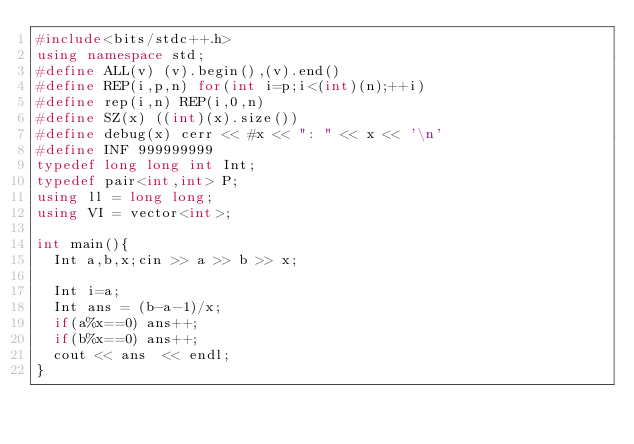Convert code to text. <code><loc_0><loc_0><loc_500><loc_500><_C++_>#include<bits/stdc++.h>
using namespace std;
#define ALL(v) (v).begin(),(v).end()
#define REP(i,p,n) for(int i=p;i<(int)(n);++i)
#define rep(i,n) REP(i,0,n)
#define SZ(x) ((int)(x).size())
#define debug(x) cerr << #x << ": " << x << '\n'
#define INF 999999999
typedef long long int Int;
typedef pair<int,int> P;
using ll = long long;
using VI = vector<int>;

int main(){
  Int a,b,x;cin >> a >> b >> x;

  Int i=a;
  Int ans = (b-a-1)/x;
  if(a%x==0) ans++;
  if(b%x==0) ans++;
  cout << ans  << endl;
}
</code> 